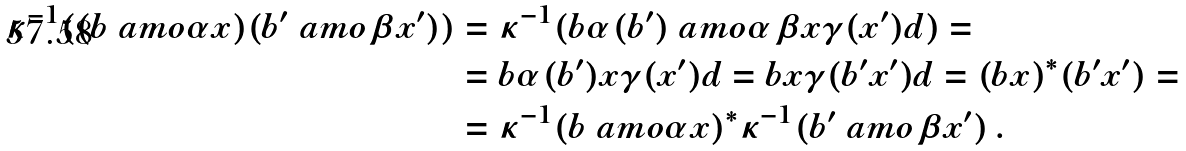Convert formula to latex. <formula><loc_0><loc_0><loc_500><loc_500>\kappa ^ { - 1 } ( ( b \ a m o { \alpha } x ) ( b ^ { \prime } \ a m o { \beta } x ^ { \prime } ) ) & = \kappa ^ { - 1 } ( b \alpha ( b ^ { \prime } ) \ a m o { \alpha \beta } x \gamma ( x ^ { \prime } ) d ) = \\ & = b \alpha ( b ^ { \prime } ) x \gamma ( x ^ { \prime } ) d = b x \gamma ( b ^ { \prime } x ^ { \prime } ) d = ( b x ) ^ { * } ( b ^ { \prime } x ^ { \prime } ) = \\ & = \kappa ^ { - 1 } ( b \ a m o { \alpha } x ) ^ { * } \kappa ^ { - 1 } ( b ^ { \prime } \ a m o { \beta } x ^ { \prime } ) \, .</formula> 